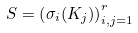<formula> <loc_0><loc_0><loc_500><loc_500>S = \left ( \sigma _ { i } ( K _ { j } ) \right ) _ { i , j = 1 } ^ { r }</formula> 